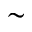<formula> <loc_0><loc_0><loc_500><loc_500>\sim</formula> 